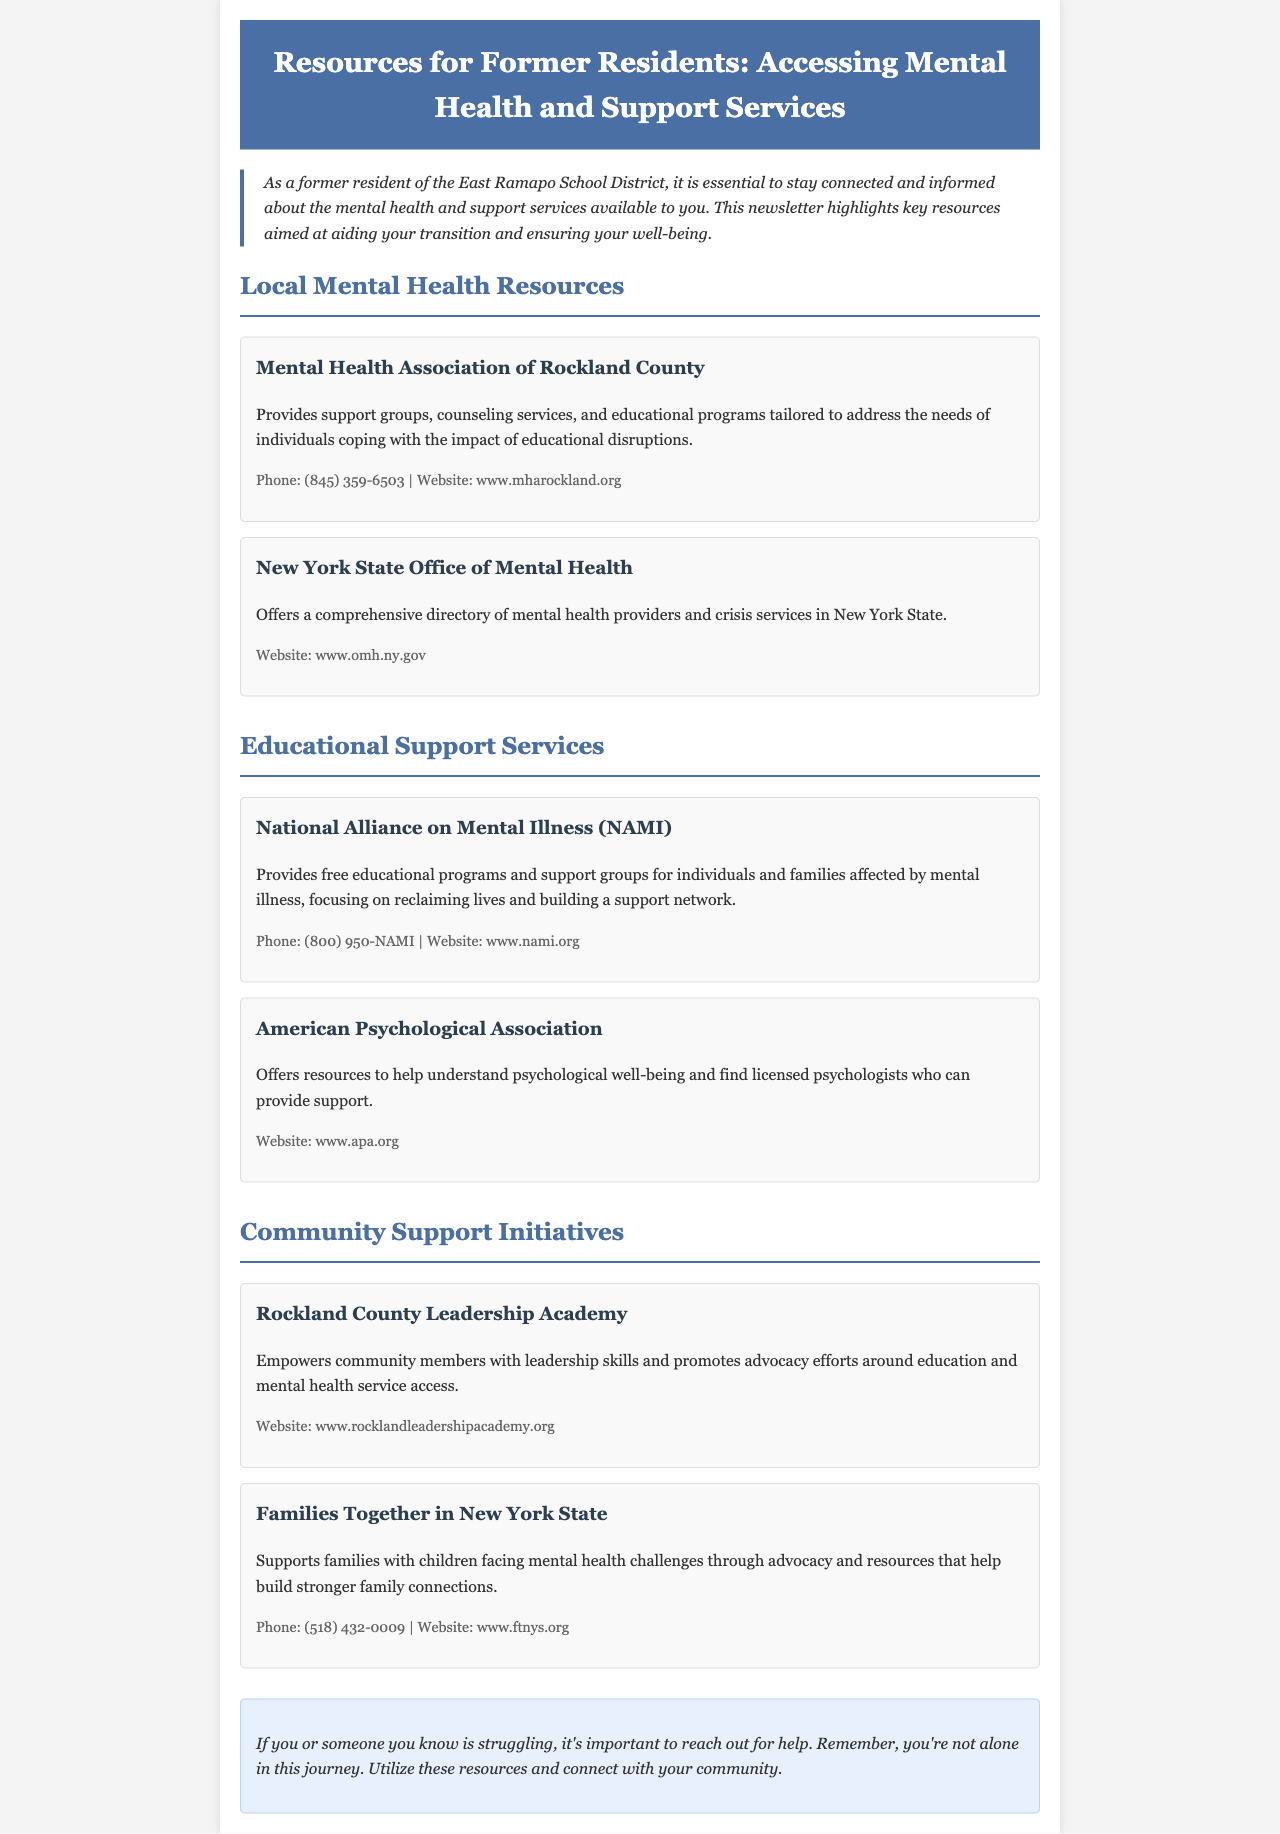What is the primary focus of the newsletter? The newsletter focuses on mental health and support services available to former residents of the East Ramapo School District.
Answer: mental health and support services What organization offers support groups in Rockland County? The organization that provides support groups is mentioned in the local mental health resources section.
Answer: Mental Health Association of Rockland County What phone number can be used to contact NAMI? NAMI's contact information is provided for support and educational programs.
Answer: (800) 950-NAMI What website offers a directory of mental health providers? The document specifies the website that provides comprehensive mental health provider information.
Answer: www.omh.ny.gov How does the Rockland County Leadership Academy support the community? The document explains that the academy empowers community members with certain skills, which is to promote advocacy.
Answer: leadership skills What type of services does Families Together in New York State provide? The document explains the role of Families Together, focusing on family support related to mental health challenges.
Answer: advocacy and resources What is the resource available for understanding psychological well-being? This section of the document identifies an organization that offers resources related to psychological well-being.
Answer: American Psychological Association What can individuals do if they are struggling according to the newsletter? The closing section provides guidance on what to do if someone is facing difficulties.
Answer: reach out for help 